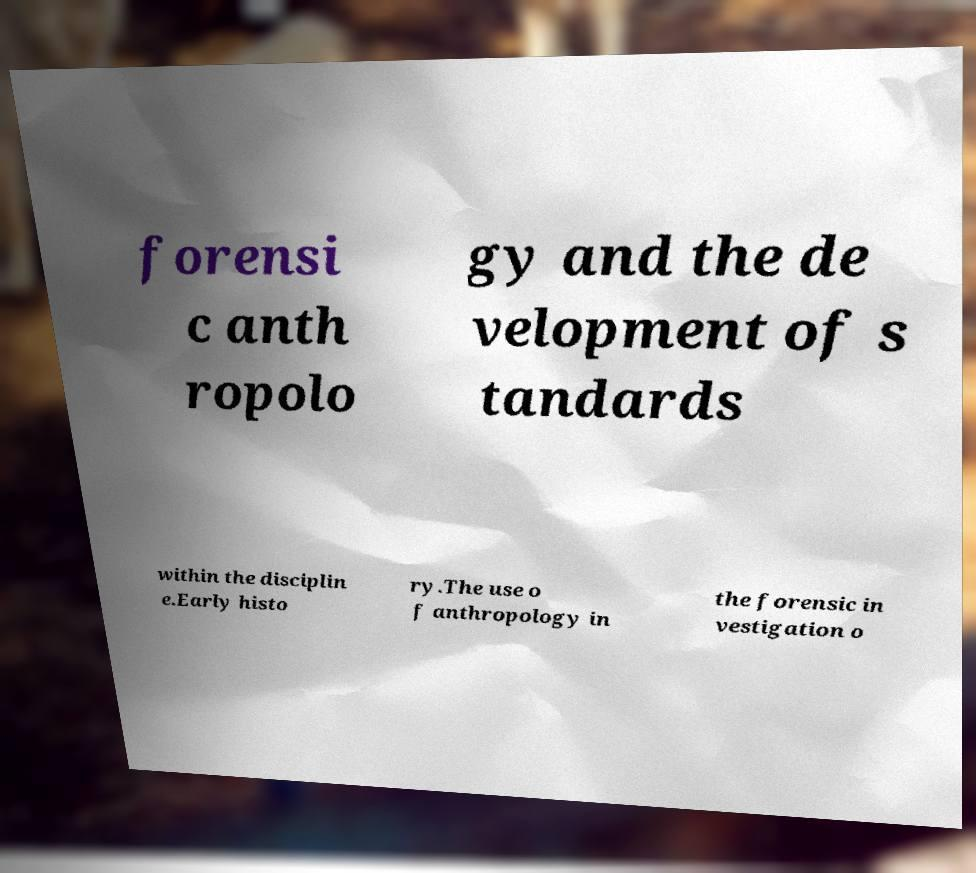There's text embedded in this image that I need extracted. Can you transcribe it verbatim? forensi c anth ropolo gy and the de velopment of s tandards within the disciplin e.Early histo ry.The use o f anthropology in the forensic in vestigation o 